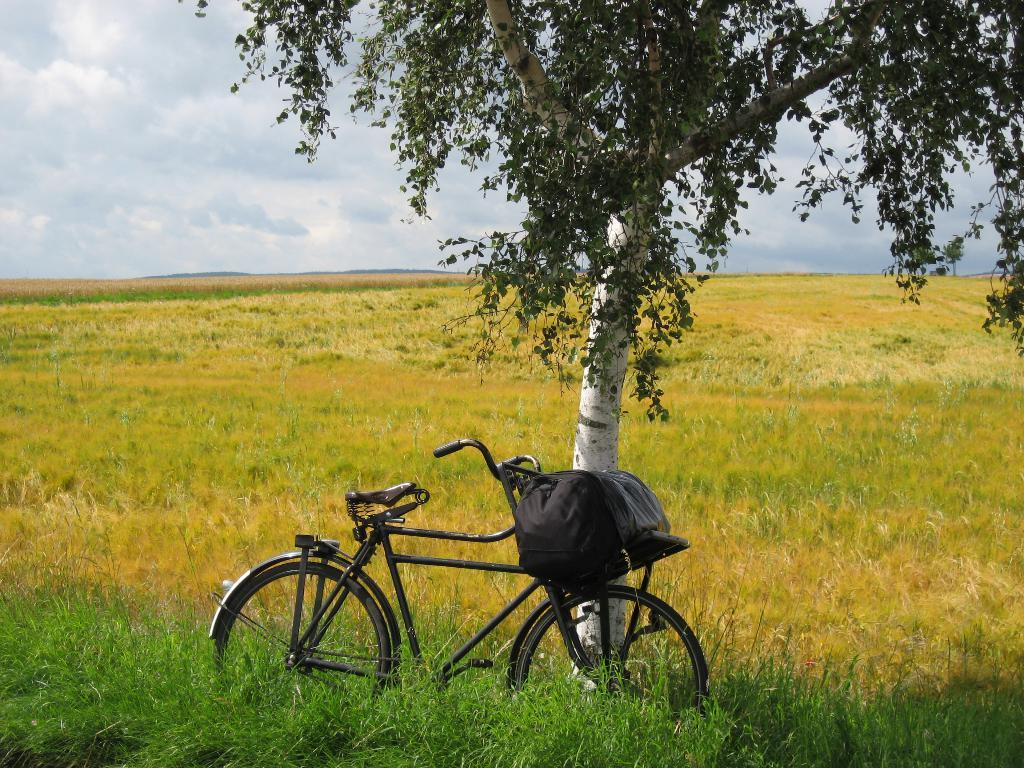What is the main object in the foreground of the image? There is a bicycle in the foreground of the image. What is attached to the bicycle? The bicycle has a bag on it. How is the bicycle positioned in the image? The bicycle is placed on the ground. What can be seen in the background of the image? There is a tree, a group of plants, and the sky visible in the background of the image. What type of garden can be seen in the image? There is no garden present in the image; it features a bicycle with a bag, a tree, a group of plants, and the sky in the background. How many balloons are tied to the bicycle in the image? There are no balloons present in the image; it only features a bicycle with a bag and no other decorations or objects. 